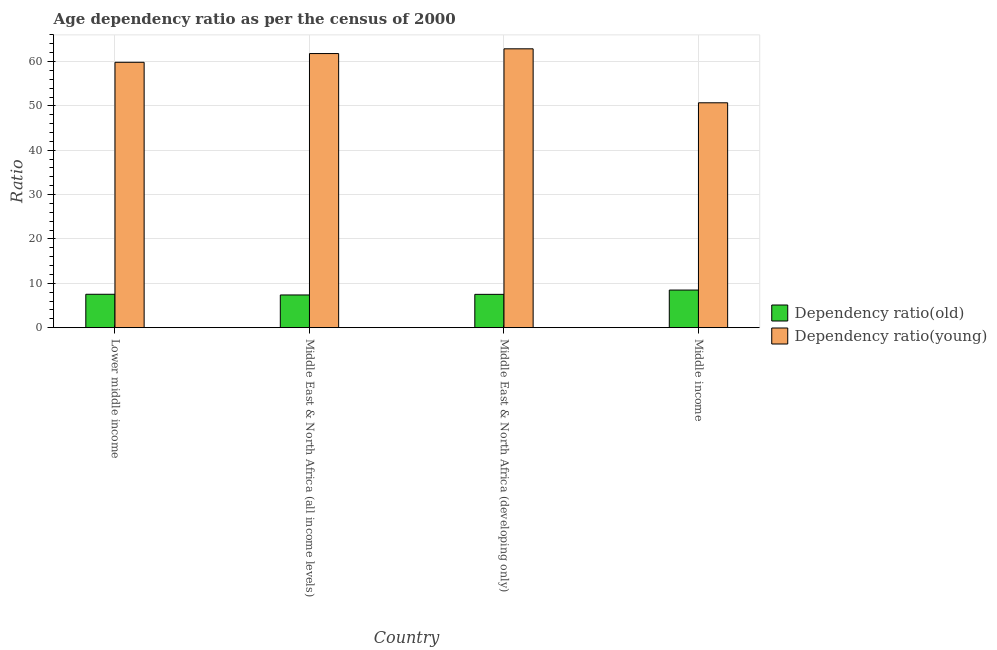How many groups of bars are there?
Provide a succinct answer. 4. Are the number of bars on each tick of the X-axis equal?
Offer a very short reply. Yes. What is the label of the 3rd group of bars from the left?
Offer a terse response. Middle East & North Africa (developing only). In how many cases, is the number of bars for a given country not equal to the number of legend labels?
Your answer should be compact. 0. What is the age dependency ratio(old) in Middle East & North Africa (developing only)?
Offer a very short reply. 7.51. Across all countries, what is the maximum age dependency ratio(young)?
Your answer should be very brief. 62.87. Across all countries, what is the minimum age dependency ratio(young)?
Keep it short and to the point. 50.7. In which country was the age dependency ratio(young) maximum?
Keep it short and to the point. Middle East & North Africa (developing only). In which country was the age dependency ratio(young) minimum?
Offer a terse response. Middle income. What is the total age dependency ratio(old) in the graph?
Ensure brevity in your answer.  30.89. What is the difference between the age dependency ratio(old) in Middle East & North Africa (all income levels) and that in Middle East & North Africa (developing only)?
Give a very brief answer. -0.14. What is the difference between the age dependency ratio(old) in Middle income and the age dependency ratio(young) in Middle East & North Africa (all income levels)?
Keep it short and to the point. -53.32. What is the average age dependency ratio(old) per country?
Keep it short and to the point. 7.72. What is the difference between the age dependency ratio(old) and age dependency ratio(young) in Middle East & North Africa (developing only)?
Ensure brevity in your answer.  -55.36. In how many countries, is the age dependency ratio(young) greater than 50 ?
Give a very brief answer. 4. What is the ratio of the age dependency ratio(young) in Lower middle income to that in Middle East & North Africa (developing only)?
Ensure brevity in your answer.  0.95. What is the difference between the highest and the second highest age dependency ratio(old)?
Provide a succinct answer. 0.95. What is the difference between the highest and the lowest age dependency ratio(old)?
Provide a short and direct response. 1.11. Is the sum of the age dependency ratio(old) in Lower middle income and Middle East & North Africa (all income levels) greater than the maximum age dependency ratio(young) across all countries?
Make the answer very short. No. What does the 1st bar from the left in Middle income represents?
Your response must be concise. Dependency ratio(old). What does the 2nd bar from the right in Middle East & North Africa (all income levels) represents?
Give a very brief answer. Dependency ratio(old). How many bars are there?
Give a very brief answer. 8. What is the difference between two consecutive major ticks on the Y-axis?
Provide a short and direct response. 10. Are the values on the major ticks of Y-axis written in scientific E-notation?
Your answer should be compact. No. Where does the legend appear in the graph?
Keep it short and to the point. Center right. What is the title of the graph?
Provide a short and direct response. Age dependency ratio as per the census of 2000. Does "International Tourists" appear as one of the legend labels in the graph?
Keep it short and to the point. No. What is the label or title of the X-axis?
Offer a very short reply. Country. What is the label or title of the Y-axis?
Offer a terse response. Ratio. What is the Ratio in Dependency ratio(old) in Lower middle income?
Provide a succinct answer. 7.53. What is the Ratio in Dependency ratio(young) in Lower middle income?
Offer a terse response. 59.83. What is the Ratio of Dependency ratio(old) in Middle East & North Africa (all income levels)?
Provide a succinct answer. 7.37. What is the Ratio in Dependency ratio(young) in Middle East & North Africa (all income levels)?
Make the answer very short. 61.8. What is the Ratio of Dependency ratio(old) in Middle East & North Africa (developing only)?
Provide a succinct answer. 7.51. What is the Ratio in Dependency ratio(young) in Middle East & North Africa (developing only)?
Provide a short and direct response. 62.87. What is the Ratio of Dependency ratio(old) in Middle income?
Offer a very short reply. 8.48. What is the Ratio in Dependency ratio(young) in Middle income?
Your response must be concise. 50.7. Across all countries, what is the maximum Ratio in Dependency ratio(old)?
Keep it short and to the point. 8.48. Across all countries, what is the maximum Ratio in Dependency ratio(young)?
Offer a very short reply. 62.87. Across all countries, what is the minimum Ratio of Dependency ratio(old)?
Your response must be concise. 7.37. Across all countries, what is the minimum Ratio of Dependency ratio(young)?
Make the answer very short. 50.7. What is the total Ratio in Dependency ratio(old) in the graph?
Keep it short and to the point. 30.89. What is the total Ratio of Dependency ratio(young) in the graph?
Keep it short and to the point. 235.19. What is the difference between the Ratio of Dependency ratio(old) in Lower middle income and that in Middle East & North Africa (all income levels)?
Offer a terse response. 0.16. What is the difference between the Ratio of Dependency ratio(young) in Lower middle income and that in Middle East & North Africa (all income levels)?
Your response must be concise. -1.97. What is the difference between the Ratio of Dependency ratio(old) in Lower middle income and that in Middle East & North Africa (developing only)?
Provide a succinct answer. 0.02. What is the difference between the Ratio of Dependency ratio(young) in Lower middle income and that in Middle East & North Africa (developing only)?
Your answer should be compact. -3.04. What is the difference between the Ratio of Dependency ratio(old) in Lower middle income and that in Middle income?
Give a very brief answer. -0.95. What is the difference between the Ratio of Dependency ratio(young) in Lower middle income and that in Middle income?
Make the answer very short. 9.13. What is the difference between the Ratio of Dependency ratio(old) in Middle East & North Africa (all income levels) and that in Middle East & North Africa (developing only)?
Offer a terse response. -0.14. What is the difference between the Ratio of Dependency ratio(young) in Middle East & North Africa (all income levels) and that in Middle East & North Africa (developing only)?
Ensure brevity in your answer.  -1.07. What is the difference between the Ratio of Dependency ratio(old) in Middle East & North Africa (all income levels) and that in Middle income?
Make the answer very short. -1.11. What is the difference between the Ratio of Dependency ratio(young) in Middle East & North Africa (all income levels) and that in Middle income?
Your answer should be very brief. 11.1. What is the difference between the Ratio of Dependency ratio(old) in Middle East & North Africa (developing only) and that in Middle income?
Make the answer very short. -0.97. What is the difference between the Ratio of Dependency ratio(young) in Middle East & North Africa (developing only) and that in Middle income?
Provide a succinct answer. 12.17. What is the difference between the Ratio in Dependency ratio(old) in Lower middle income and the Ratio in Dependency ratio(young) in Middle East & North Africa (all income levels)?
Your answer should be very brief. -54.27. What is the difference between the Ratio of Dependency ratio(old) in Lower middle income and the Ratio of Dependency ratio(young) in Middle East & North Africa (developing only)?
Your response must be concise. -55.34. What is the difference between the Ratio in Dependency ratio(old) in Lower middle income and the Ratio in Dependency ratio(young) in Middle income?
Your answer should be compact. -43.17. What is the difference between the Ratio in Dependency ratio(old) in Middle East & North Africa (all income levels) and the Ratio in Dependency ratio(young) in Middle East & North Africa (developing only)?
Your answer should be compact. -55.49. What is the difference between the Ratio of Dependency ratio(old) in Middle East & North Africa (all income levels) and the Ratio of Dependency ratio(young) in Middle income?
Your response must be concise. -43.33. What is the difference between the Ratio in Dependency ratio(old) in Middle East & North Africa (developing only) and the Ratio in Dependency ratio(young) in Middle income?
Your answer should be very brief. -43.19. What is the average Ratio in Dependency ratio(old) per country?
Provide a succinct answer. 7.72. What is the average Ratio of Dependency ratio(young) per country?
Your answer should be compact. 58.8. What is the difference between the Ratio in Dependency ratio(old) and Ratio in Dependency ratio(young) in Lower middle income?
Offer a very short reply. -52.3. What is the difference between the Ratio in Dependency ratio(old) and Ratio in Dependency ratio(young) in Middle East & North Africa (all income levels)?
Your response must be concise. -54.43. What is the difference between the Ratio in Dependency ratio(old) and Ratio in Dependency ratio(young) in Middle East & North Africa (developing only)?
Your response must be concise. -55.36. What is the difference between the Ratio in Dependency ratio(old) and Ratio in Dependency ratio(young) in Middle income?
Make the answer very short. -42.22. What is the ratio of the Ratio of Dependency ratio(old) in Lower middle income to that in Middle East & North Africa (all income levels)?
Offer a very short reply. 1.02. What is the ratio of the Ratio of Dependency ratio(young) in Lower middle income to that in Middle East & North Africa (all income levels)?
Make the answer very short. 0.97. What is the ratio of the Ratio of Dependency ratio(young) in Lower middle income to that in Middle East & North Africa (developing only)?
Your response must be concise. 0.95. What is the ratio of the Ratio of Dependency ratio(old) in Lower middle income to that in Middle income?
Provide a succinct answer. 0.89. What is the ratio of the Ratio in Dependency ratio(young) in Lower middle income to that in Middle income?
Give a very brief answer. 1.18. What is the ratio of the Ratio in Dependency ratio(old) in Middle East & North Africa (all income levels) to that in Middle East & North Africa (developing only)?
Give a very brief answer. 0.98. What is the ratio of the Ratio in Dependency ratio(young) in Middle East & North Africa (all income levels) to that in Middle East & North Africa (developing only)?
Give a very brief answer. 0.98. What is the ratio of the Ratio in Dependency ratio(old) in Middle East & North Africa (all income levels) to that in Middle income?
Ensure brevity in your answer.  0.87. What is the ratio of the Ratio of Dependency ratio(young) in Middle East & North Africa (all income levels) to that in Middle income?
Your answer should be compact. 1.22. What is the ratio of the Ratio in Dependency ratio(old) in Middle East & North Africa (developing only) to that in Middle income?
Your answer should be compact. 0.89. What is the ratio of the Ratio of Dependency ratio(young) in Middle East & North Africa (developing only) to that in Middle income?
Your answer should be compact. 1.24. What is the difference between the highest and the second highest Ratio in Dependency ratio(old)?
Offer a terse response. 0.95. What is the difference between the highest and the second highest Ratio in Dependency ratio(young)?
Provide a succinct answer. 1.07. What is the difference between the highest and the lowest Ratio of Dependency ratio(old)?
Your response must be concise. 1.11. What is the difference between the highest and the lowest Ratio of Dependency ratio(young)?
Provide a short and direct response. 12.17. 